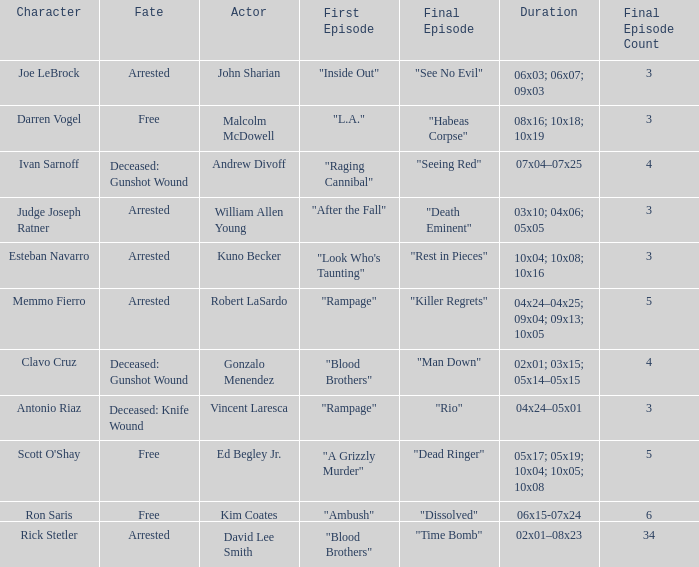What's the character with fate being deceased: knife wound Antonio Riaz. 